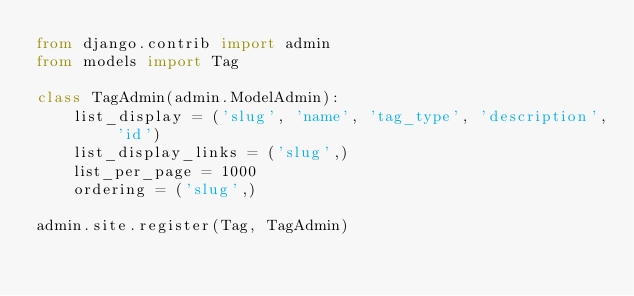<code> <loc_0><loc_0><loc_500><loc_500><_Python_>from django.contrib import admin
from models import Tag

class TagAdmin(admin.ModelAdmin):
    list_display = ('slug', 'name', 'tag_type', 'description', 'id')
    list_display_links = ('slug',)
    list_per_page = 1000
    ordering = ('slug',)

admin.site.register(Tag, TagAdmin)
</code> 